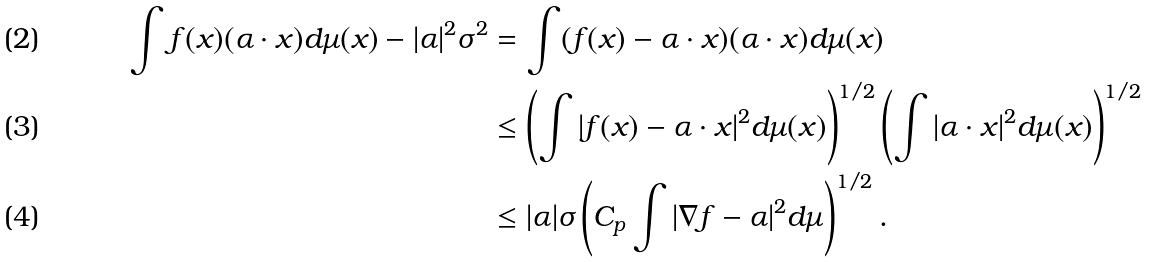Convert formula to latex. <formula><loc_0><loc_0><loc_500><loc_500>\int f ( x ) ( \alpha \cdot x ) d \mu ( x ) - | \alpha | ^ { 2 } \sigma ^ { 2 } & = \int ( f ( x ) - \alpha \cdot x ) ( \alpha \cdot x ) d \mu ( x ) \\ & \leq \left ( \int | f ( x ) - \alpha \cdot x | ^ { 2 } d \mu ( x ) \right ) ^ { 1 / 2 } \left ( \int | \alpha \cdot x | ^ { 2 } d \mu ( x ) \right ) ^ { 1 / 2 } \\ & \leq | \alpha | \sigma \left ( C _ { p } \int | \nabla f - \alpha | ^ { 2 } d \mu \right ) ^ { 1 / 2 } .</formula> 